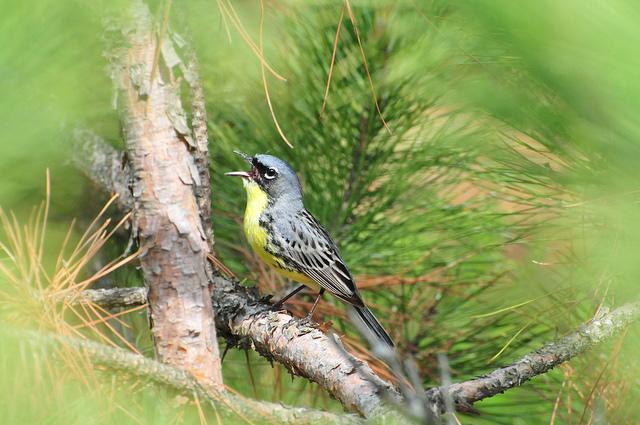What color is this bird?
Be succinct. Yellow and gray. How many birds are pictured?
Quick response, please. 1. What kind of tree is the bird in?
Quick response, please. Pine. What bright color is under the birds beak?
Keep it brief. Yellow. 